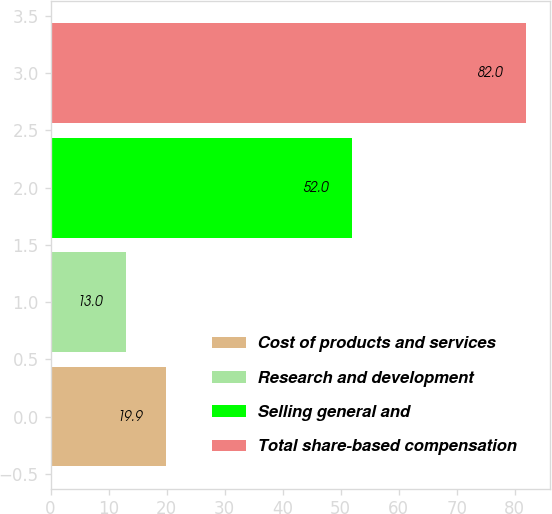Convert chart. <chart><loc_0><loc_0><loc_500><loc_500><bar_chart><fcel>Cost of products and services<fcel>Research and development<fcel>Selling general and<fcel>Total share-based compensation<nl><fcel>19.9<fcel>13<fcel>52<fcel>82<nl></chart> 